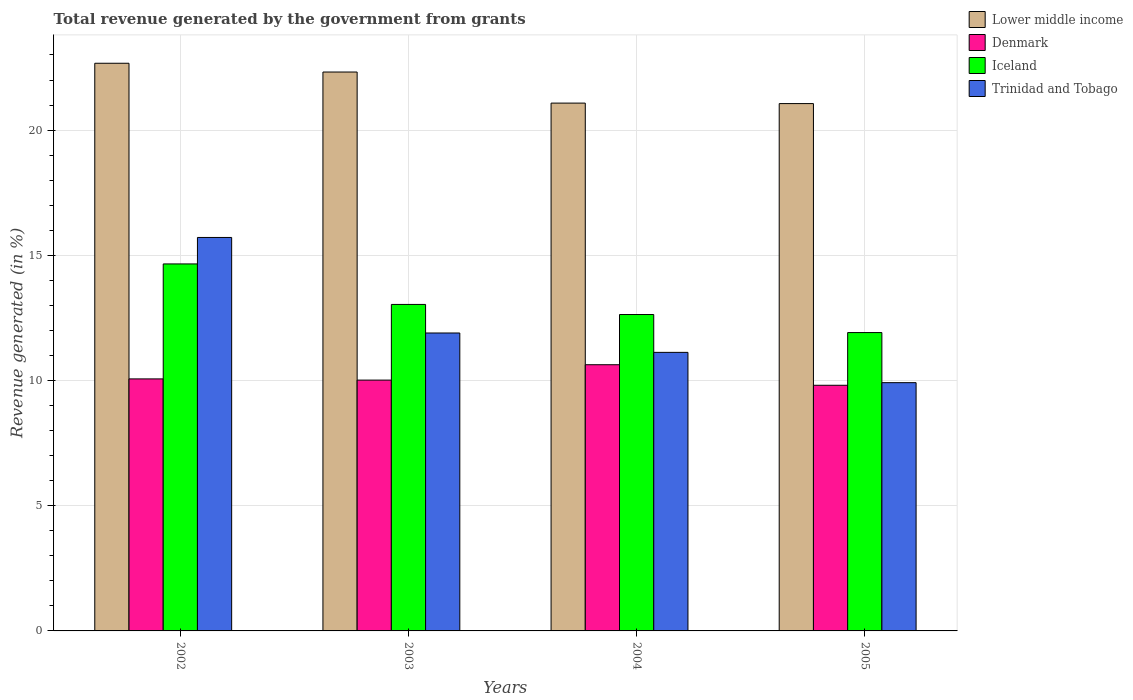How many bars are there on the 2nd tick from the left?
Provide a short and direct response. 4. How many bars are there on the 1st tick from the right?
Your answer should be compact. 4. In how many cases, is the number of bars for a given year not equal to the number of legend labels?
Offer a terse response. 0. What is the total revenue generated in Lower middle income in 2002?
Offer a very short reply. 22.67. Across all years, what is the maximum total revenue generated in Denmark?
Keep it short and to the point. 10.63. Across all years, what is the minimum total revenue generated in Iceland?
Give a very brief answer. 11.91. In which year was the total revenue generated in Trinidad and Tobago maximum?
Your answer should be compact. 2002. In which year was the total revenue generated in Denmark minimum?
Your response must be concise. 2005. What is the total total revenue generated in Lower middle income in the graph?
Offer a very short reply. 87.12. What is the difference between the total revenue generated in Iceland in 2002 and that in 2005?
Offer a very short reply. 2.74. What is the difference between the total revenue generated in Lower middle income in 2005 and the total revenue generated in Trinidad and Tobago in 2002?
Ensure brevity in your answer.  5.35. What is the average total revenue generated in Iceland per year?
Provide a short and direct response. 13.06. In the year 2004, what is the difference between the total revenue generated in Denmark and total revenue generated in Lower middle income?
Keep it short and to the point. -10.45. In how many years, is the total revenue generated in Trinidad and Tobago greater than 8 %?
Keep it short and to the point. 4. What is the ratio of the total revenue generated in Iceland in 2002 to that in 2003?
Your response must be concise. 1.12. Is the difference between the total revenue generated in Denmark in 2002 and 2004 greater than the difference between the total revenue generated in Lower middle income in 2002 and 2004?
Your response must be concise. No. What is the difference between the highest and the second highest total revenue generated in Lower middle income?
Your answer should be compact. 0.35. What is the difference between the highest and the lowest total revenue generated in Iceland?
Your response must be concise. 2.74. In how many years, is the total revenue generated in Iceland greater than the average total revenue generated in Iceland taken over all years?
Offer a very short reply. 1. What does the 1st bar from the left in 2004 represents?
Your answer should be very brief. Lower middle income. What does the 3rd bar from the right in 2005 represents?
Make the answer very short. Denmark. Are all the bars in the graph horizontal?
Your answer should be compact. No. How many years are there in the graph?
Provide a succinct answer. 4. What is the difference between two consecutive major ticks on the Y-axis?
Keep it short and to the point. 5. Does the graph contain any zero values?
Make the answer very short. No. Where does the legend appear in the graph?
Provide a short and direct response. Top right. What is the title of the graph?
Provide a succinct answer. Total revenue generated by the government from grants. Does "Malawi" appear as one of the legend labels in the graph?
Your response must be concise. No. What is the label or title of the X-axis?
Ensure brevity in your answer.  Years. What is the label or title of the Y-axis?
Give a very brief answer. Revenue generated (in %). What is the Revenue generated (in %) of Lower middle income in 2002?
Keep it short and to the point. 22.67. What is the Revenue generated (in %) in Denmark in 2002?
Your response must be concise. 10.06. What is the Revenue generated (in %) of Iceland in 2002?
Give a very brief answer. 14.66. What is the Revenue generated (in %) in Trinidad and Tobago in 2002?
Your response must be concise. 15.71. What is the Revenue generated (in %) of Lower middle income in 2003?
Offer a terse response. 22.32. What is the Revenue generated (in %) of Denmark in 2003?
Give a very brief answer. 10.02. What is the Revenue generated (in %) of Iceland in 2003?
Your answer should be compact. 13.04. What is the Revenue generated (in %) in Trinidad and Tobago in 2003?
Make the answer very short. 11.9. What is the Revenue generated (in %) in Lower middle income in 2004?
Provide a short and direct response. 21.08. What is the Revenue generated (in %) in Denmark in 2004?
Your answer should be compact. 10.63. What is the Revenue generated (in %) in Iceland in 2004?
Your answer should be compact. 12.63. What is the Revenue generated (in %) of Trinidad and Tobago in 2004?
Make the answer very short. 11.12. What is the Revenue generated (in %) in Lower middle income in 2005?
Offer a very short reply. 21.06. What is the Revenue generated (in %) in Denmark in 2005?
Make the answer very short. 9.81. What is the Revenue generated (in %) of Iceland in 2005?
Ensure brevity in your answer.  11.91. What is the Revenue generated (in %) in Trinidad and Tobago in 2005?
Provide a succinct answer. 9.91. Across all years, what is the maximum Revenue generated (in %) in Lower middle income?
Your response must be concise. 22.67. Across all years, what is the maximum Revenue generated (in %) of Denmark?
Make the answer very short. 10.63. Across all years, what is the maximum Revenue generated (in %) in Iceland?
Your answer should be compact. 14.66. Across all years, what is the maximum Revenue generated (in %) in Trinidad and Tobago?
Your answer should be compact. 15.71. Across all years, what is the minimum Revenue generated (in %) in Lower middle income?
Keep it short and to the point. 21.06. Across all years, what is the minimum Revenue generated (in %) in Denmark?
Provide a short and direct response. 9.81. Across all years, what is the minimum Revenue generated (in %) in Iceland?
Provide a succinct answer. 11.91. Across all years, what is the minimum Revenue generated (in %) in Trinidad and Tobago?
Give a very brief answer. 9.91. What is the total Revenue generated (in %) in Lower middle income in the graph?
Ensure brevity in your answer.  87.12. What is the total Revenue generated (in %) in Denmark in the graph?
Make the answer very short. 40.52. What is the total Revenue generated (in %) in Iceland in the graph?
Your answer should be very brief. 52.24. What is the total Revenue generated (in %) in Trinidad and Tobago in the graph?
Your response must be concise. 48.65. What is the difference between the Revenue generated (in %) of Lower middle income in 2002 and that in 2003?
Offer a terse response. 0.35. What is the difference between the Revenue generated (in %) in Denmark in 2002 and that in 2003?
Keep it short and to the point. 0.05. What is the difference between the Revenue generated (in %) in Iceland in 2002 and that in 2003?
Offer a very short reply. 1.62. What is the difference between the Revenue generated (in %) of Trinidad and Tobago in 2002 and that in 2003?
Your answer should be very brief. 3.81. What is the difference between the Revenue generated (in %) of Lower middle income in 2002 and that in 2004?
Offer a terse response. 1.59. What is the difference between the Revenue generated (in %) of Denmark in 2002 and that in 2004?
Offer a terse response. -0.57. What is the difference between the Revenue generated (in %) of Iceland in 2002 and that in 2004?
Provide a short and direct response. 2.02. What is the difference between the Revenue generated (in %) of Trinidad and Tobago in 2002 and that in 2004?
Your answer should be compact. 4.59. What is the difference between the Revenue generated (in %) of Lower middle income in 2002 and that in 2005?
Make the answer very short. 1.61. What is the difference between the Revenue generated (in %) in Denmark in 2002 and that in 2005?
Offer a terse response. 0.25. What is the difference between the Revenue generated (in %) in Iceland in 2002 and that in 2005?
Offer a terse response. 2.74. What is the difference between the Revenue generated (in %) in Trinidad and Tobago in 2002 and that in 2005?
Offer a terse response. 5.8. What is the difference between the Revenue generated (in %) in Lower middle income in 2003 and that in 2004?
Keep it short and to the point. 1.24. What is the difference between the Revenue generated (in %) in Denmark in 2003 and that in 2004?
Offer a very short reply. -0.61. What is the difference between the Revenue generated (in %) in Iceland in 2003 and that in 2004?
Your answer should be very brief. 0.4. What is the difference between the Revenue generated (in %) in Trinidad and Tobago in 2003 and that in 2004?
Your response must be concise. 0.77. What is the difference between the Revenue generated (in %) in Lower middle income in 2003 and that in 2005?
Your response must be concise. 1.26. What is the difference between the Revenue generated (in %) of Denmark in 2003 and that in 2005?
Make the answer very short. 0.21. What is the difference between the Revenue generated (in %) of Iceland in 2003 and that in 2005?
Ensure brevity in your answer.  1.12. What is the difference between the Revenue generated (in %) in Trinidad and Tobago in 2003 and that in 2005?
Keep it short and to the point. 1.98. What is the difference between the Revenue generated (in %) of Lower middle income in 2004 and that in 2005?
Provide a succinct answer. 0.02. What is the difference between the Revenue generated (in %) in Denmark in 2004 and that in 2005?
Keep it short and to the point. 0.82. What is the difference between the Revenue generated (in %) in Iceland in 2004 and that in 2005?
Your response must be concise. 0.72. What is the difference between the Revenue generated (in %) of Trinidad and Tobago in 2004 and that in 2005?
Make the answer very short. 1.21. What is the difference between the Revenue generated (in %) of Lower middle income in 2002 and the Revenue generated (in %) of Denmark in 2003?
Your response must be concise. 12.65. What is the difference between the Revenue generated (in %) in Lower middle income in 2002 and the Revenue generated (in %) in Iceland in 2003?
Your answer should be very brief. 9.63. What is the difference between the Revenue generated (in %) of Lower middle income in 2002 and the Revenue generated (in %) of Trinidad and Tobago in 2003?
Give a very brief answer. 10.77. What is the difference between the Revenue generated (in %) of Denmark in 2002 and the Revenue generated (in %) of Iceland in 2003?
Offer a very short reply. -2.97. What is the difference between the Revenue generated (in %) in Denmark in 2002 and the Revenue generated (in %) in Trinidad and Tobago in 2003?
Give a very brief answer. -1.83. What is the difference between the Revenue generated (in %) in Iceland in 2002 and the Revenue generated (in %) in Trinidad and Tobago in 2003?
Provide a short and direct response. 2.76. What is the difference between the Revenue generated (in %) in Lower middle income in 2002 and the Revenue generated (in %) in Denmark in 2004?
Keep it short and to the point. 12.04. What is the difference between the Revenue generated (in %) in Lower middle income in 2002 and the Revenue generated (in %) in Iceland in 2004?
Your answer should be very brief. 10.03. What is the difference between the Revenue generated (in %) of Lower middle income in 2002 and the Revenue generated (in %) of Trinidad and Tobago in 2004?
Your response must be concise. 11.55. What is the difference between the Revenue generated (in %) of Denmark in 2002 and the Revenue generated (in %) of Iceland in 2004?
Provide a succinct answer. -2.57. What is the difference between the Revenue generated (in %) of Denmark in 2002 and the Revenue generated (in %) of Trinidad and Tobago in 2004?
Your response must be concise. -1.06. What is the difference between the Revenue generated (in %) in Iceland in 2002 and the Revenue generated (in %) in Trinidad and Tobago in 2004?
Provide a succinct answer. 3.53. What is the difference between the Revenue generated (in %) in Lower middle income in 2002 and the Revenue generated (in %) in Denmark in 2005?
Provide a short and direct response. 12.86. What is the difference between the Revenue generated (in %) of Lower middle income in 2002 and the Revenue generated (in %) of Iceland in 2005?
Provide a short and direct response. 10.75. What is the difference between the Revenue generated (in %) of Lower middle income in 2002 and the Revenue generated (in %) of Trinidad and Tobago in 2005?
Your answer should be compact. 12.75. What is the difference between the Revenue generated (in %) in Denmark in 2002 and the Revenue generated (in %) in Iceland in 2005?
Keep it short and to the point. -1.85. What is the difference between the Revenue generated (in %) in Denmark in 2002 and the Revenue generated (in %) in Trinidad and Tobago in 2005?
Keep it short and to the point. 0.15. What is the difference between the Revenue generated (in %) of Iceland in 2002 and the Revenue generated (in %) of Trinidad and Tobago in 2005?
Make the answer very short. 4.74. What is the difference between the Revenue generated (in %) in Lower middle income in 2003 and the Revenue generated (in %) in Denmark in 2004?
Provide a short and direct response. 11.69. What is the difference between the Revenue generated (in %) in Lower middle income in 2003 and the Revenue generated (in %) in Iceland in 2004?
Your answer should be compact. 9.68. What is the difference between the Revenue generated (in %) of Lower middle income in 2003 and the Revenue generated (in %) of Trinidad and Tobago in 2004?
Offer a terse response. 11.2. What is the difference between the Revenue generated (in %) of Denmark in 2003 and the Revenue generated (in %) of Iceland in 2004?
Your response must be concise. -2.62. What is the difference between the Revenue generated (in %) in Denmark in 2003 and the Revenue generated (in %) in Trinidad and Tobago in 2004?
Provide a short and direct response. -1.11. What is the difference between the Revenue generated (in %) of Iceland in 2003 and the Revenue generated (in %) of Trinidad and Tobago in 2004?
Provide a succinct answer. 1.91. What is the difference between the Revenue generated (in %) in Lower middle income in 2003 and the Revenue generated (in %) in Denmark in 2005?
Your response must be concise. 12.51. What is the difference between the Revenue generated (in %) in Lower middle income in 2003 and the Revenue generated (in %) in Iceland in 2005?
Offer a terse response. 10.4. What is the difference between the Revenue generated (in %) of Lower middle income in 2003 and the Revenue generated (in %) of Trinidad and Tobago in 2005?
Your answer should be very brief. 12.41. What is the difference between the Revenue generated (in %) of Denmark in 2003 and the Revenue generated (in %) of Iceland in 2005?
Give a very brief answer. -1.9. What is the difference between the Revenue generated (in %) in Denmark in 2003 and the Revenue generated (in %) in Trinidad and Tobago in 2005?
Provide a succinct answer. 0.1. What is the difference between the Revenue generated (in %) in Iceland in 2003 and the Revenue generated (in %) in Trinidad and Tobago in 2005?
Your answer should be compact. 3.12. What is the difference between the Revenue generated (in %) in Lower middle income in 2004 and the Revenue generated (in %) in Denmark in 2005?
Give a very brief answer. 11.27. What is the difference between the Revenue generated (in %) in Lower middle income in 2004 and the Revenue generated (in %) in Iceland in 2005?
Your response must be concise. 9.16. What is the difference between the Revenue generated (in %) in Lower middle income in 2004 and the Revenue generated (in %) in Trinidad and Tobago in 2005?
Offer a terse response. 11.16. What is the difference between the Revenue generated (in %) in Denmark in 2004 and the Revenue generated (in %) in Iceland in 2005?
Your response must be concise. -1.28. What is the difference between the Revenue generated (in %) of Denmark in 2004 and the Revenue generated (in %) of Trinidad and Tobago in 2005?
Your answer should be compact. 0.72. What is the difference between the Revenue generated (in %) in Iceland in 2004 and the Revenue generated (in %) in Trinidad and Tobago in 2005?
Make the answer very short. 2.72. What is the average Revenue generated (in %) in Lower middle income per year?
Provide a succinct answer. 21.78. What is the average Revenue generated (in %) of Denmark per year?
Your answer should be compact. 10.13. What is the average Revenue generated (in %) of Iceland per year?
Your response must be concise. 13.06. What is the average Revenue generated (in %) of Trinidad and Tobago per year?
Give a very brief answer. 12.16. In the year 2002, what is the difference between the Revenue generated (in %) of Lower middle income and Revenue generated (in %) of Denmark?
Your answer should be very brief. 12.6. In the year 2002, what is the difference between the Revenue generated (in %) in Lower middle income and Revenue generated (in %) in Iceland?
Make the answer very short. 8.01. In the year 2002, what is the difference between the Revenue generated (in %) in Lower middle income and Revenue generated (in %) in Trinidad and Tobago?
Keep it short and to the point. 6.96. In the year 2002, what is the difference between the Revenue generated (in %) in Denmark and Revenue generated (in %) in Iceland?
Your answer should be very brief. -4.59. In the year 2002, what is the difference between the Revenue generated (in %) of Denmark and Revenue generated (in %) of Trinidad and Tobago?
Give a very brief answer. -5.65. In the year 2002, what is the difference between the Revenue generated (in %) of Iceland and Revenue generated (in %) of Trinidad and Tobago?
Offer a terse response. -1.06. In the year 2003, what is the difference between the Revenue generated (in %) of Lower middle income and Revenue generated (in %) of Denmark?
Keep it short and to the point. 12.3. In the year 2003, what is the difference between the Revenue generated (in %) in Lower middle income and Revenue generated (in %) in Iceland?
Keep it short and to the point. 9.28. In the year 2003, what is the difference between the Revenue generated (in %) in Lower middle income and Revenue generated (in %) in Trinidad and Tobago?
Make the answer very short. 10.42. In the year 2003, what is the difference between the Revenue generated (in %) of Denmark and Revenue generated (in %) of Iceland?
Provide a short and direct response. -3.02. In the year 2003, what is the difference between the Revenue generated (in %) of Denmark and Revenue generated (in %) of Trinidad and Tobago?
Ensure brevity in your answer.  -1.88. In the year 2003, what is the difference between the Revenue generated (in %) in Iceland and Revenue generated (in %) in Trinidad and Tobago?
Give a very brief answer. 1.14. In the year 2004, what is the difference between the Revenue generated (in %) of Lower middle income and Revenue generated (in %) of Denmark?
Your response must be concise. 10.45. In the year 2004, what is the difference between the Revenue generated (in %) in Lower middle income and Revenue generated (in %) in Iceland?
Provide a succinct answer. 8.44. In the year 2004, what is the difference between the Revenue generated (in %) in Lower middle income and Revenue generated (in %) in Trinidad and Tobago?
Offer a terse response. 9.95. In the year 2004, what is the difference between the Revenue generated (in %) of Denmark and Revenue generated (in %) of Iceland?
Keep it short and to the point. -2. In the year 2004, what is the difference between the Revenue generated (in %) in Denmark and Revenue generated (in %) in Trinidad and Tobago?
Offer a very short reply. -0.49. In the year 2004, what is the difference between the Revenue generated (in %) of Iceland and Revenue generated (in %) of Trinidad and Tobago?
Give a very brief answer. 1.51. In the year 2005, what is the difference between the Revenue generated (in %) in Lower middle income and Revenue generated (in %) in Denmark?
Offer a very short reply. 11.25. In the year 2005, what is the difference between the Revenue generated (in %) of Lower middle income and Revenue generated (in %) of Iceland?
Ensure brevity in your answer.  9.14. In the year 2005, what is the difference between the Revenue generated (in %) in Lower middle income and Revenue generated (in %) in Trinidad and Tobago?
Your answer should be compact. 11.14. In the year 2005, what is the difference between the Revenue generated (in %) in Denmark and Revenue generated (in %) in Iceland?
Offer a terse response. -2.1. In the year 2005, what is the difference between the Revenue generated (in %) of Denmark and Revenue generated (in %) of Trinidad and Tobago?
Offer a very short reply. -0.1. In the year 2005, what is the difference between the Revenue generated (in %) in Iceland and Revenue generated (in %) in Trinidad and Tobago?
Provide a short and direct response. 2. What is the ratio of the Revenue generated (in %) in Lower middle income in 2002 to that in 2003?
Your answer should be compact. 1.02. What is the ratio of the Revenue generated (in %) in Denmark in 2002 to that in 2003?
Your answer should be very brief. 1. What is the ratio of the Revenue generated (in %) of Iceland in 2002 to that in 2003?
Your answer should be very brief. 1.12. What is the ratio of the Revenue generated (in %) in Trinidad and Tobago in 2002 to that in 2003?
Make the answer very short. 1.32. What is the ratio of the Revenue generated (in %) in Lower middle income in 2002 to that in 2004?
Keep it short and to the point. 1.08. What is the ratio of the Revenue generated (in %) of Denmark in 2002 to that in 2004?
Make the answer very short. 0.95. What is the ratio of the Revenue generated (in %) of Iceland in 2002 to that in 2004?
Your response must be concise. 1.16. What is the ratio of the Revenue generated (in %) in Trinidad and Tobago in 2002 to that in 2004?
Ensure brevity in your answer.  1.41. What is the ratio of the Revenue generated (in %) in Lower middle income in 2002 to that in 2005?
Give a very brief answer. 1.08. What is the ratio of the Revenue generated (in %) in Denmark in 2002 to that in 2005?
Provide a succinct answer. 1.03. What is the ratio of the Revenue generated (in %) of Iceland in 2002 to that in 2005?
Your answer should be very brief. 1.23. What is the ratio of the Revenue generated (in %) of Trinidad and Tobago in 2002 to that in 2005?
Provide a succinct answer. 1.58. What is the ratio of the Revenue generated (in %) in Lower middle income in 2003 to that in 2004?
Your response must be concise. 1.06. What is the ratio of the Revenue generated (in %) of Denmark in 2003 to that in 2004?
Ensure brevity in your answer.  0.94. What is the ratio of the Revenue generated (in %) of Iceland in 2003 to that in 2004?
Provide a succinct answer. 1.03. What is the ratio of the Revenue generated (in %) in Trinidad and Tobago in 2003 to that in 2004?
Your answer should be very brief. 1.07. What is the ratio of the Revenue generated (in %) in Lower middle income in 2003 to that in 2005?
Provide a short and direct response. 1.06. What is the ratio of the Revenue generated (in %) in Denmark in 2003 to that in 2005?
Keep it short and to the point. 1.02. What is the ratio of the Revenue generated (in %) of Iceland in 2003 to that in 2005?
Offer a very short reply. 1.09. What is the ratio of the Revenue generated (in %) in Trinidad and Tobago in 2003 to that in 2005?
Offer a very short reply. 1.2. What is the ratio of the Revenue generated (in %) of Lower middle income in 2004 to that in 2005?
Keep it short and to the point. 1. What is the ratio of the Revenue generated (in %) in Denmark in 2004 to that in 2005?
Your answer should be compact. 1.08. What is the ratio of the Revenue generated (in %) in Iceland in 2004 to that in 2005?
Provide a short and direct response. 1.06. What is the ratio of the Revenue generated (in %) of Trinidad and Tobago in 2004 to that in 2005?
Provide a succinct answer. 1.12. What is the difference between the highest and the second highest Revenue generated (in %) of Lower middle income?
Ensure brevity in your answer.  0.35. What is the difference between the highest and the second highest Revenue generated (in %) in Denmark?
Your response must be concise. 0.57. What is the difference between the highest and the second highest Revenue generated (in %) of Iceland?
Keep it short and to the point. 1.62. What is the difference between the highest and the second highest Revenue generated (in %) in Trinidad and Tobago?
Keep it short and to the point. 3.81. What is the difference between the highest and the lowest Revenue generated (in %) of Lower middle income?
Your response must be concise. 1.61. What is the difference between the highest and the lowest Revenue generated (in %) in Denmark?
Provide a short and direct response. 0.82. What is the difference between the highest and the lowest Revenue generated (in %) of Iceland?
Offer a terse response. 2.74. What is the difference between the highest and the lowest Revenue generated (in %) in Trinidad and Tobago?
Provide a succinct answer. 5.8. 